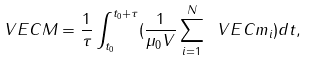Convert formula to latex. <formula><loc_0><loc_0><loc_500><loc_500>\ V E C M = \frac { 1 } { \tau } \int ^ { t _ { 0 } + \tau } _ { t _ { 0 } } ( \frac { 1 } { \mu _ { 0 } V } \sum _ { i = 1 } ^ { N } \ V E C m _ { i } ) d t ,</formula> 